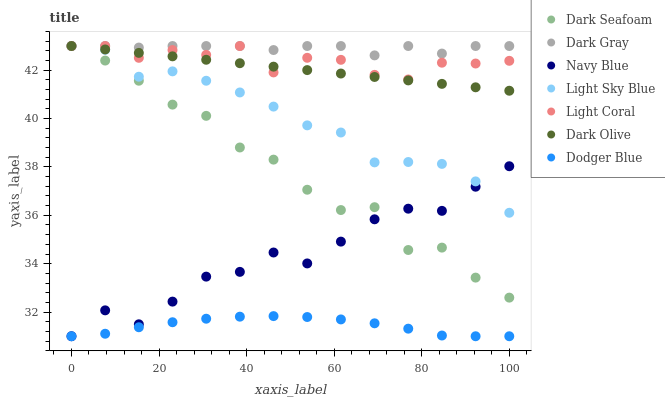Does Dodger Blue have the minimum area under the curve?
Answer yes or no. Yes. Does Dark Gray have the maximum area under the curve?
Answer yes or no. Yes. Does Navy Blue have the minimum area under the curve?
Answer yes or no. No. Does Navy Blue have the maximum area under the curve?
Answer yes or no. No. Is Dark Olive the smoothest?
Answer yes or no. Yes. Is Dark Seafoam the roughest?
Answer yes or no. Yes. Is Navy Blue the smoothest?
Answer yes or no. No. Is Navy Blue the roughest?
Answer yes or no. No. Does Navy Blue have the lowest value?
Answer yes or no. Yes. Does Dark Olive have the lowest value?
Answer yes or no. No. Does Light Sky Blue have the highest value?
Answer yes or no. Yes. Does Navy Blue have the highest value?
Answer yes or no. No. Is Navy Blue less than Light Coral?
Answer yes or no. Yes. Is Dark Gray greater than Navy Blue?
Answer yes or no. Yes. Does Light Sky Blue intersect Navy Blue?
Answer yes or no. Yes. Is Light Sky Blue less than Navy Blue?
Answer yes or no. No. Is Light Sky Blue greater than Navy Blue?
Answer yes or no. No. Does Navy Blue intersect Light Coral?
Answer yes or no. No. 